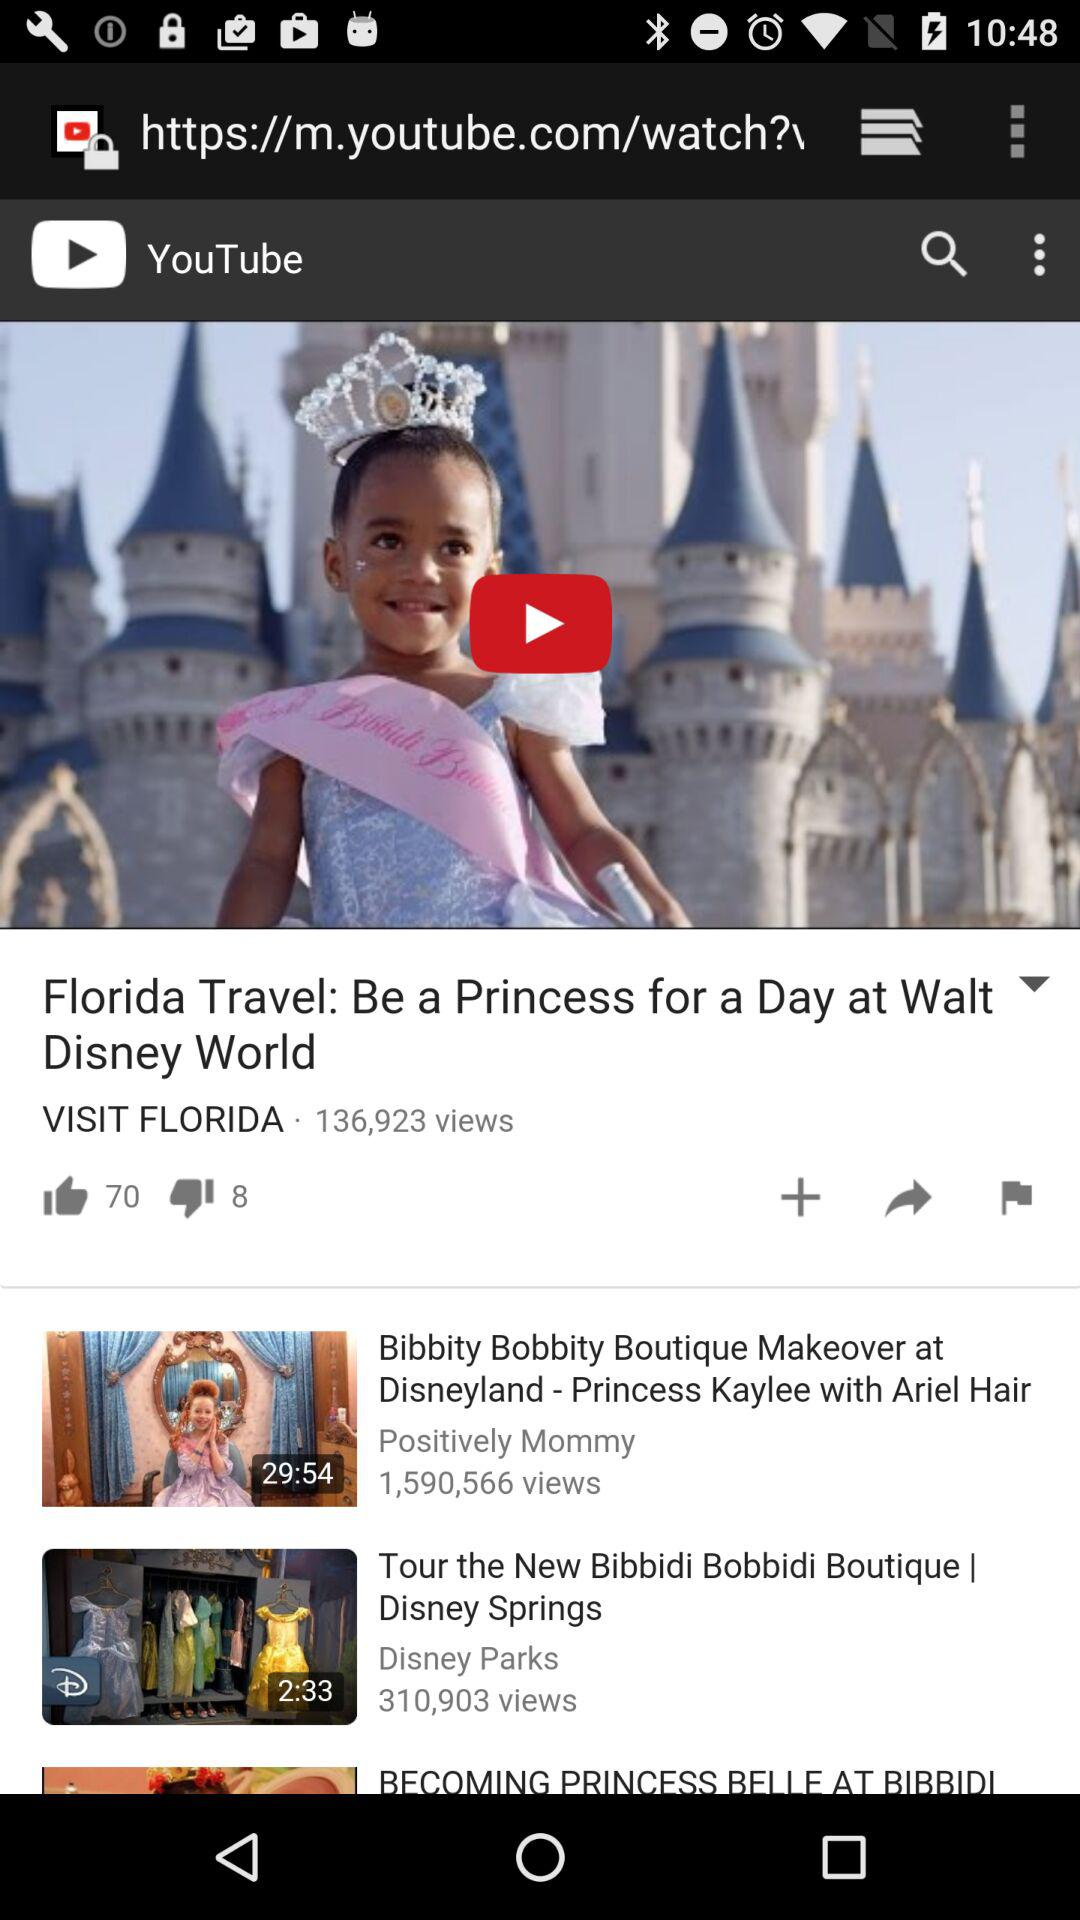What is the number of views of the "Tour the New Bibbidi Bobbidi Boutique | Disney Springs" video? The number of views is 310,903. 